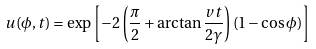<formula> <loc_0><loc_0><loc_500><loc_500>u ( \phi , t ) = \exp \left [ - 2 \left ( \frac { \pi } { 2 } + \arctan \frac { v t } { 2 \gamma } \right ) ( 1 - \cos \phi ) \right ]</formula> 